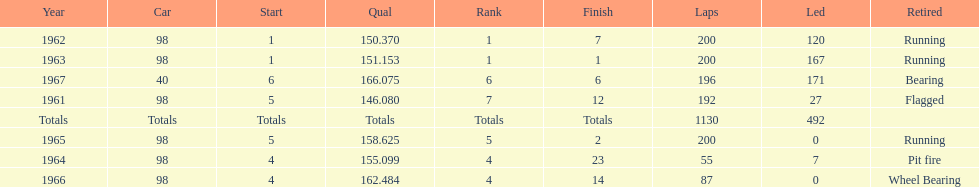What year(s) did parnelli finish at least 4th or better? 1963, 1965. 